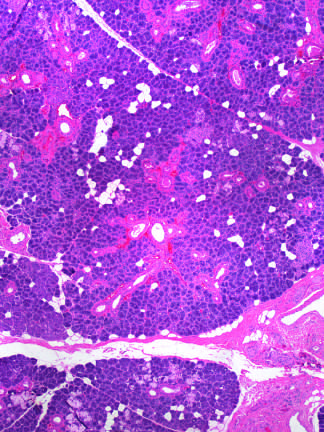re vascular changes and fibrosis of salivary glands produced by radiation therapy of the neck region?
Answer the question using a single word or phrase. Yes 